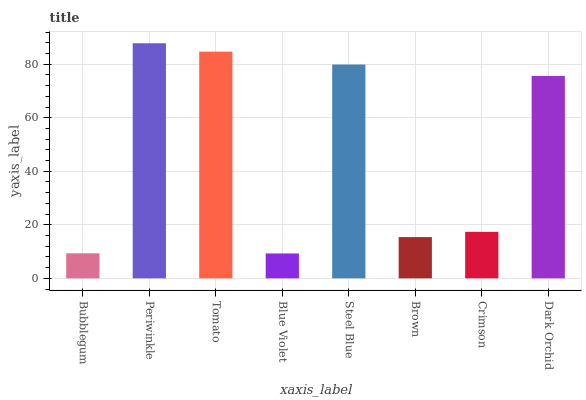Is Blue Violet the minimum?
Answer yes or no. Yes. Is Periwinkle the maximum?
Answer yes or no. Yes. Is Tomato the minimum?
Answer yes or no. No. Is Tomato the maximum?
Answer yes or no. No. Is Periwinkle greater than Tomato?
Answer yes or no. Yes. Is Tomato less than Periwinkle?
Answer yes or no. Yes. Is Tomato greater than Periwinkle?
Answer yes or no. No. Is Periwinkle less than Tomato?
Answer yes or no. No. Is Dark Orchid the high median?
Answer yes or no. Yes. Is Crimson the low median?
Answer yes or no. Yes. Is Periwinkle the high median?
Answer yes or no. No. Is Periwinkle the low median?
Answer yes or no. No. 